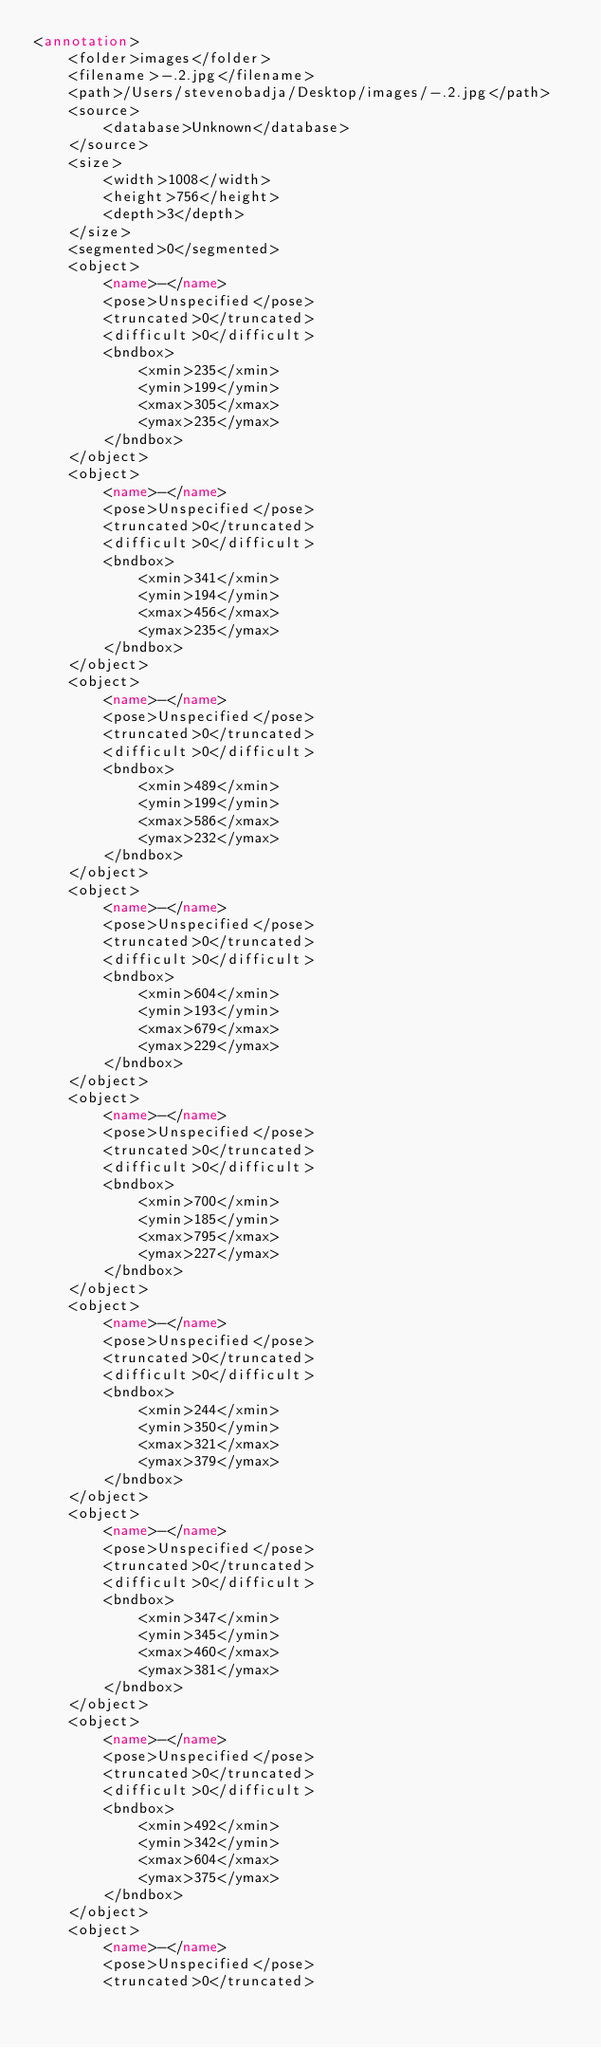<code> <loc_0><loc_0><loc_500><loc_500><_XML_><annotation>
	<folder>images</folder>
	<filename>-.2.jpg</filename>
	<path>/Users/stevenobadja/Desktop/images/-.2.jpg</path>
	<source>
		<database>Unknown</database>
	</source>
	<size>
		<width>1008</width>
		<height>756</height>
		<depth>3</depth>
	</size>
	<segmented>0</segmented>
	<object>
		<name>-</name>
		<pose>Unspecified</pose>
		<truncated>0</truncated>
		<difficult>0</difficult>
		<bndbox>
			<xmin>235</xmin>
			<ymin>199</ymin>
			<xmax>305</xmax>
			<ymax>235</ymax>
		</bndbox>
	</object>
	<object>
		<name>-</name>
		<pose>Unspecified</pose>
		<truncated>0</truncated>
		<difficult>0</difficult>
		<bndbox>
			<xmin>341</xmin>
			<ymin>194</ymin>
			<xmax>456</xmax>
			<ymax>235</ymax>
		</bndbox>
	</object>
	<object>
		<name>-</name>
		<pose>Unspecified</pose>
		<truncated>0</truncated>
		<difficult>0</difficult>
		<bndbox>
			<xmin>489</xmin>
			<ymin>199</ymin>
			<xmax>586</xmax>
			<ymax>232</ymax>
		</bndbox>
	</object>
	<object>
		<name>-</name>
		<pose>Unspecified</pose>
		<truncated>0</truncated>
		<difficult>0</difficult>
		<bndbox>
			<xmin>604</xmin>
			<ymin>193</ymin>
			<xmax>679</xmax>
			<ymax>229</ymax>
		</bndbox>
	</object>
	<object>
		<name>-</name>
		<pose>Unspecified</pose>
		<truncated>0</truncated>
		<difficult>0</difficult>
		<bndbox>
			<xmin>700</xmin>
			<ymin>185</ymin>
			<xmax>795</xmax>
			<ymax>227</ymax>
		</bndbox>
	</object>
	<object>
		<name>-</name>
		<pose>Unspecified</pose>
		<truncated>0</truncated>
		<difficult>0</difficult>
		<bndbox>
			<xmin>244</xmin>
			<ymin>350</ymin>
			<xmax>321</xmax>
			<ymax>379</ymax>
		</bndbox>
	</object>
	<object>
		<name>-</name>
		<pose>Unspecified</pose>
		<truncated>0</truncated>
		<difficult>0</difficult>
		<bndbox>
			<xmin>347</xmin>
			<ymin>345</ymin>
			<xmax>460</xmax>
			<ymax>381</ymax>
		</bndbox>
	</object>
	<object>
		<name>-</name>
		<pose>Unspecified</pose>
		<truncated>0</truncated>
		<difficult>0</difficult>
		<bndbox>
			<xmin>492</xmin>
			<ymin>342</ymin>
			<xmax>604</xmax>
			<ymax>375</ymax>
		</bndbox>
	</object>
	<object>
		<name>-</name>
		<pose>Unspecified</pose>
		<truncated>0</truncated></code> 